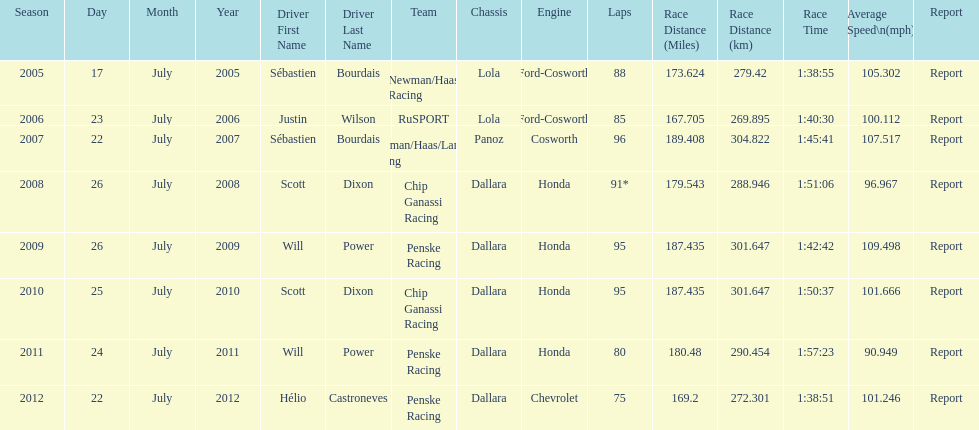How many flags other than france (the first flag) are represented? 3. 